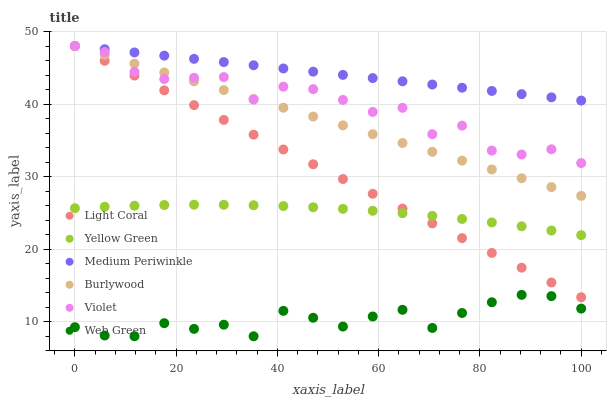Does Web Green have the minimum area under the curve?
Answer yes or no. Yes. Does Medium Periwinkle have the maximum area under the curve?
Answer yes or no. Yes. Does Burlywood have the minimum area under the curve?
Answer yes or no. No. Does Burlywood have the maximum area under the curve?
Answer yes or no. No. Is Light Coral the smoothest?
Answer yes or no. Yes. Is Violet the roughest?
Answer yes or no. Yes. Is Burlywood the smoothest?
Answer yes or no. No. Is Burlywood the roughest?
Answer yes or no. No. Does Web Green have the lowest value?
Answer yes or no. Yes. Does Burlywood have the lowest value?
Answer yes or no. No. Does Violet have the highest value?
Answer yes or no. Yes. Does Web Green have the highest value?
Answer yes or no. No. Is Yellow Green less than Burlywood?
Answer yes or no. Yes. Is Medium Periwinkle greater than Web Green?
Answer yes or no. Yes. Does Burlywood intersect Violet?
Answer yes or no. Yes. Is Burlywood less than Violet?
Answer yes or no. No. Is Burlywood greater than Violet?
Answer yes or no. No. Does Yellow Green intersect Burlywood?
Answer yes or no. No. 